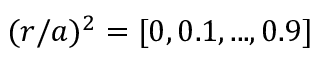Convert formula to latex. <formula><loc_0><loc_0><loc_500><loc_500>( r / a ) ^ { 2 } = [ 0 , 0 . 1 , \dots , 0 . 9 ]</formula> 